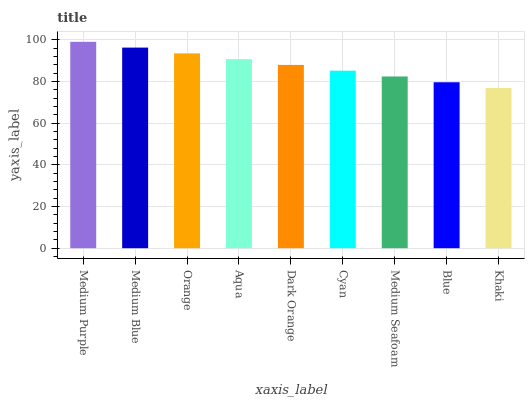Is Khaki the minimum?
Answer yes or no. Yes. Is Medium Purple the maximum?
Answer yes or no. Yes. Is Medium Blue the minimum?
Answer yes or no. No. Is Medium Blue the maximum?
Answer yes or no. No. Is Medium Purple greater than Medium Blue?
Answer yes or no. Yes. Is Medium Blue less than Medium Purple?
Answer yes or no. Yes. Is Medium Blue greater than Medium Purple?
Answer yes or no. No. Is Medium Purple less than Medium Blue?
Answer yes or no. No. Is Dark Orange the high median?
Answer yes or no. Yes. Is Dark Orange the low median?
Answer yes or no. Yes. Is Medium Seafoam the high median?
Answer yes or no. No. Is Medium Blue the low median?
Answer yes or no. No. 